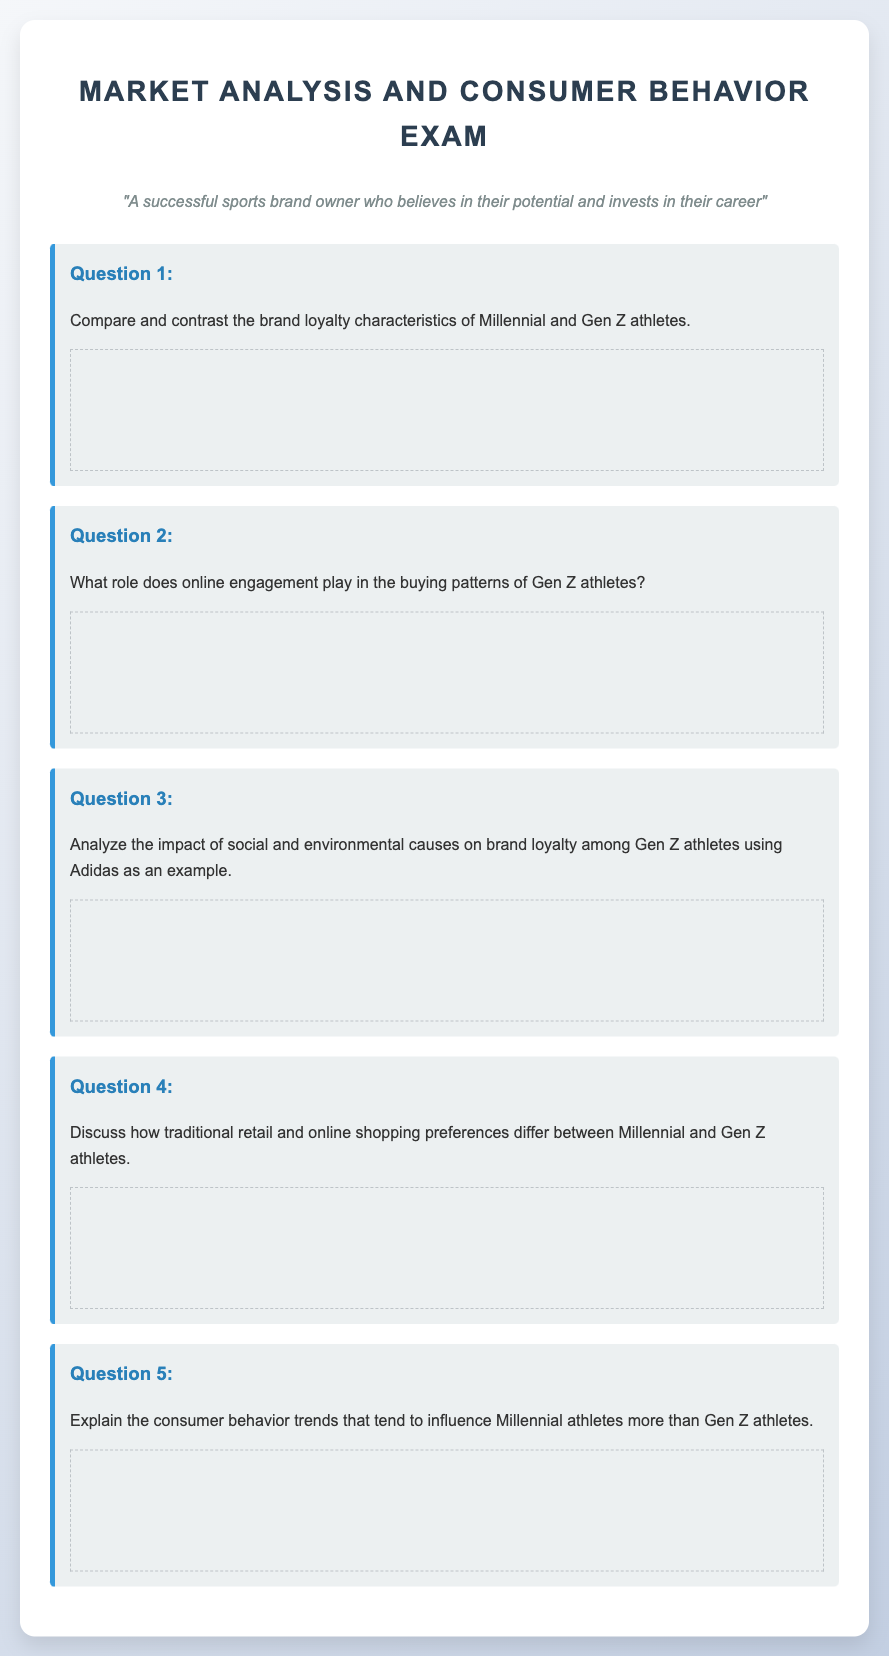What is the title of the exam? The title of the exam is prominently displayed in the document.
Answer: Sports Brand Market Analysis Exam How many questions are included in the exam? The document lists a specific number of questions in the exam section.
Answer: 5 What demographic groups are being compared in the study? The study focuses on two demographic groups regarding brand loyalty and buying patterns.
Answer: Millennial and Gen Z athletes What brand is used as an example to analyze brand loyalty in the document? The document specifically mentions a brand in the context of Gen Z athletes' loyalty.
Answer: Adidas What is the overarching theme of the questions in the exam? The questions are centered around a specific aspect of consumer behavior and market analysis.
Answer: Brand loyalty and buying patterns 